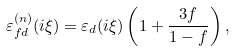Convert formula to latex. <formula><loc_0><loc_0><loc_500><loc_500>\varepsilon _ { f d } ^ { ( n ) } ( i \xi ) = \varepsilon _ { d } ( i \xi ) \left ( 1 + \frac { 3 f } { 1 - f } \right ) ,</formula> 